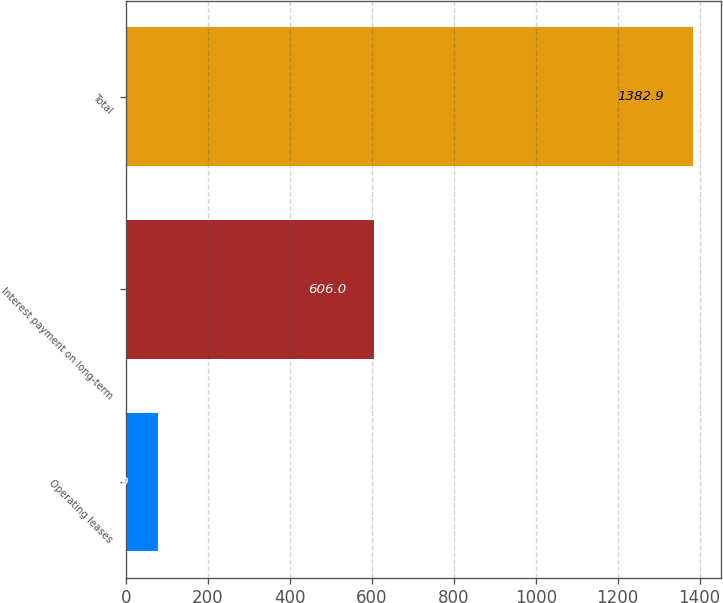Convert chart. <chart><loc_0><loc_0><loc_500><loc_500><bar_chart><fcel>Operating leases<fcel>Interest payment on long-term<fcel>Total<nl><fcel>76.9<fcel>606<fcel>1382.9<nl></chart> 